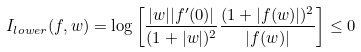Convert formula to latex. <formula><loc_0><loc_0><loc_500><loc_500>I _ { l o w e r } ( f , w ) = \log { \left [ \frac { | w | | f ^ { \prime } ( 0 ) | } { ( 1 + | w | ) ^ { 2 } } \frac { ( 1 + | f ( w ) | ) ^ { 2 } } { | f ( w ) | } \right ] } \leq 0</formula> 